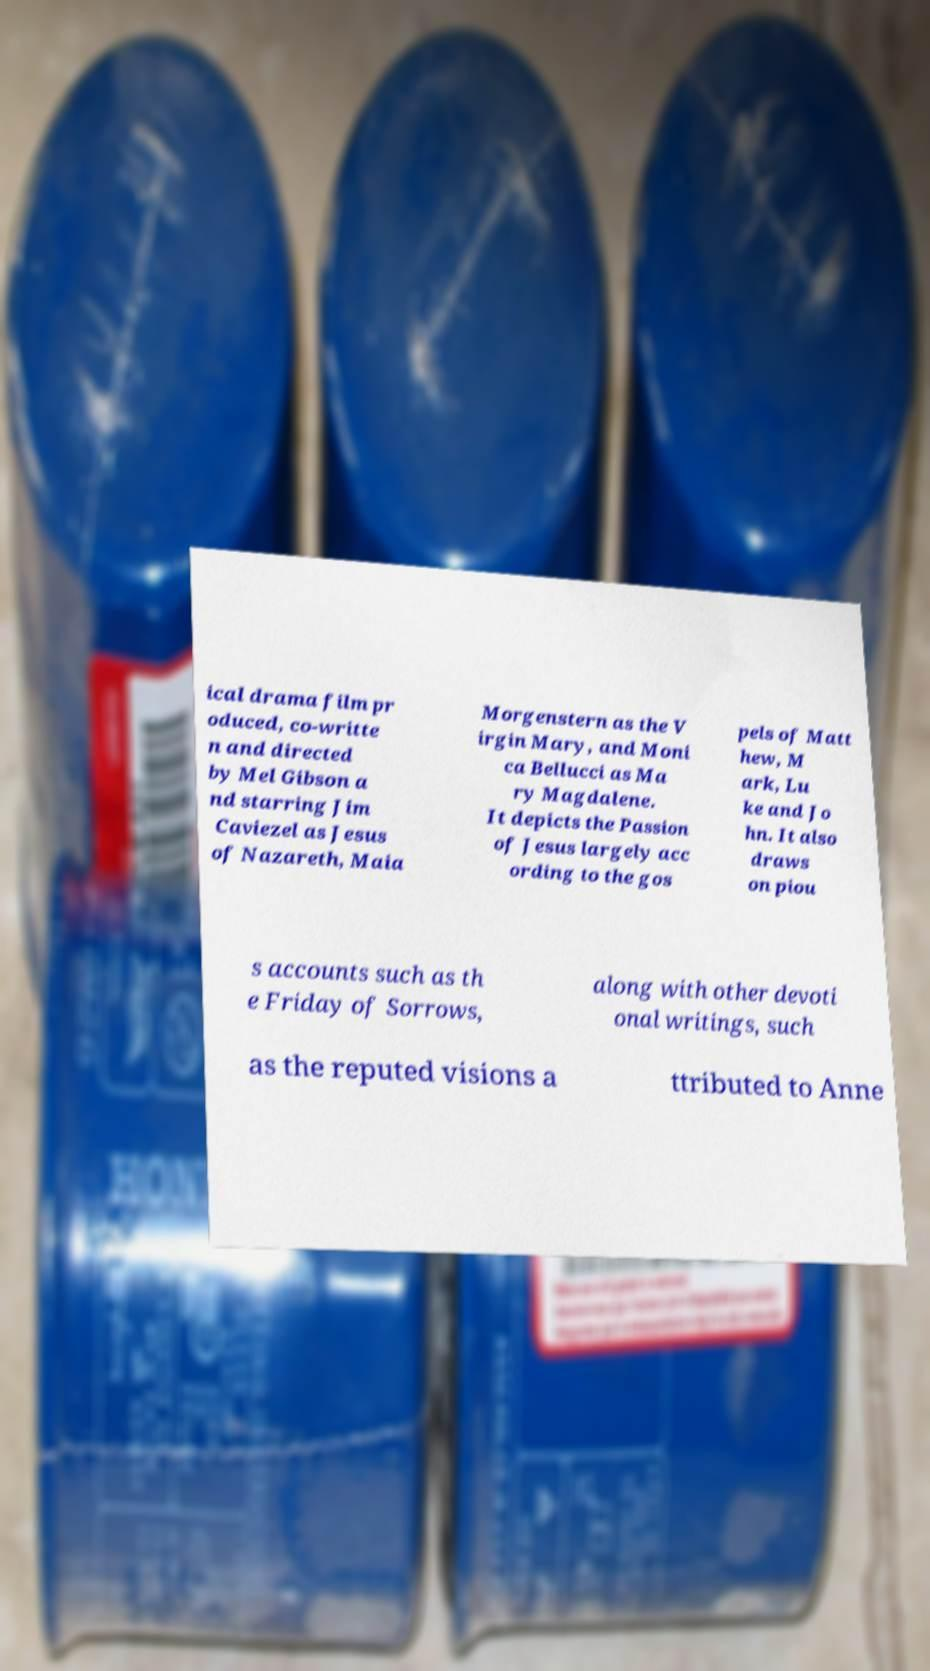Could you assist in decoding the text presented in this image and type it out clearly? ical drama film pr oduced, co-writte n and directed by Mel Gibson a nd starring Jim Caviezel as Jesus of Nazareth, Maia Morgenstern as the V irgin Mary, and Moni ca Bellucci as Ma ry Magdalene. It depicts the Passion of Jesus largely acc ording to the gos pels of Matt hew, M ark, Lu ke and Jo hn. It also draws on piou s accounts such as th e Friday of Sorrows, along with other devoti onal writings, such as the reputed visions a ttributed to Anne 